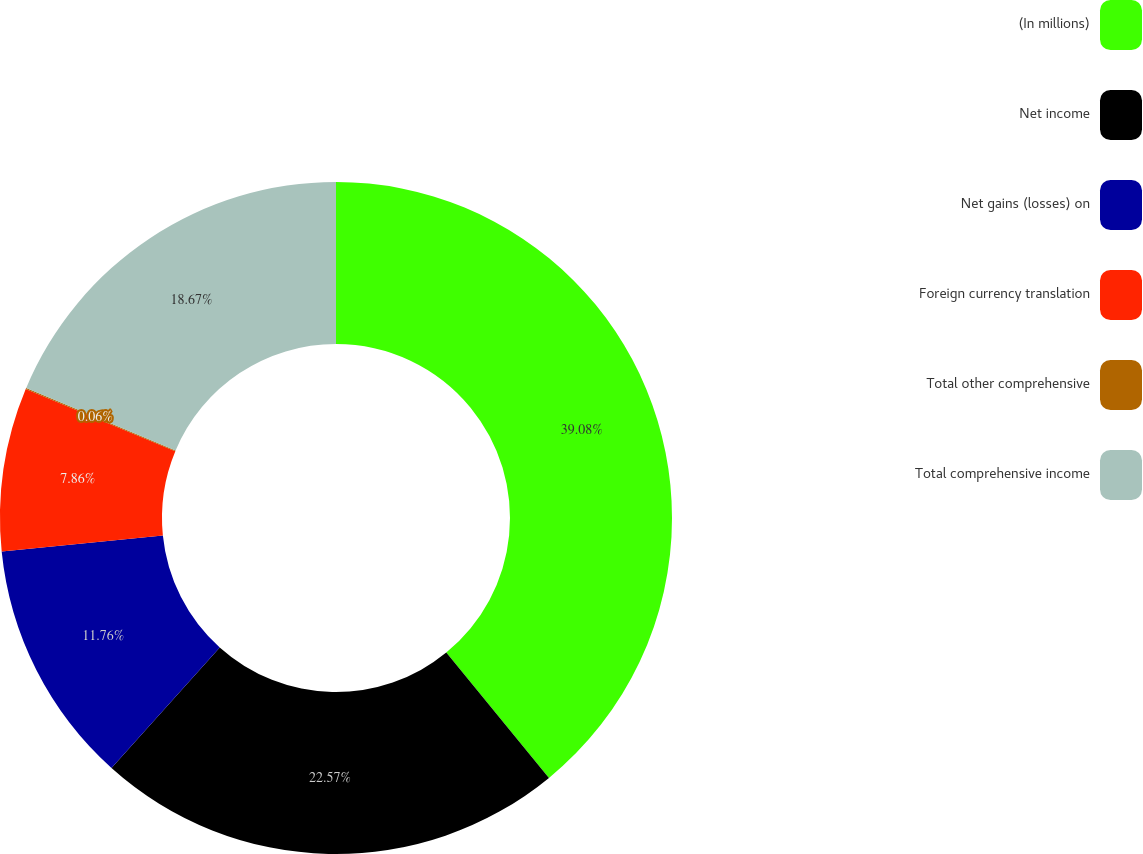Convert chart to OTSL. <chart><loc_0><loc_0><loc_500><loc_500><pie_chart><fcel>(In millions)<fcel>Net income<fcel>Net gains (losses) on<fcel>Foreign currency translation<fcel>Total other comprehensive<fcel>Total comprehensive income<nl><fcel>39.07%<fcel>22.57%<fcel>11.76%<fcel>7.86%<fcel>0.06%<fcel>18.67%<nl></chart> 